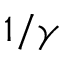<formula> <loc_0><loc_0><loc_500><loc_500>1 / \gamma</formula> 